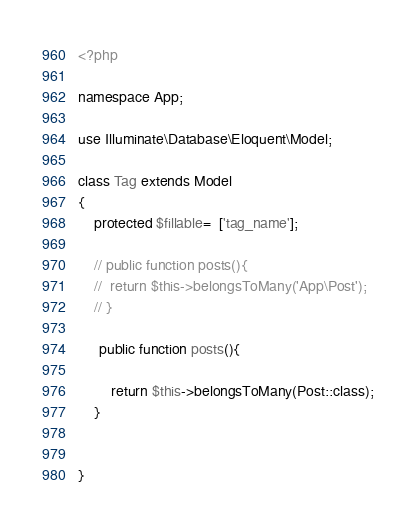Convert code to text. <code><loc_0><loc_0><loc_500><loc_500><_PHP_><?php

namespace App;

use Illuminate\Database\Eloquent\Model;

class Tag extends Model
{
    protected $fillable=  ['tag_name'];

    // public function posts(){
    // 	return $this->belongsToMany('App\Post');
    // }

     public function posts(){
        
    	return $this->belongsToMany(Post::class);
    }

    
}
</code> 